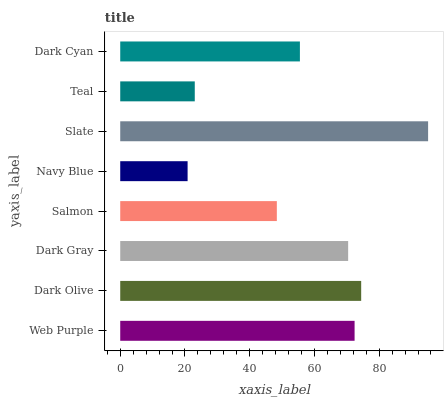Is Navy Blue the minimum?
Answer yes or no. Yes. Is Slate the maximum?
Answer yes or no. Yes. Is Dark Olive the minimum?
Answer yes or no. No. Is Dark Olive the maximum?
Answer yes or no. No. Is Dark Olive greater than Web Purple?
Answer yes or no. Yes. Is Web Purple less than Dark Olive?
Answer yes or no. Yes. Is Web Purple greater than Dark Olive?
Answer yes or no. No. Is Dark Olive less than Web Purple?
Answer yes or no. No. Is Dark Gray the high median?
Answer yes or no. Yes. Is Dark Cyan the low median?
Answer yes or no. Yes. Is Dark Olive the high median?
Answer yes or no. No. Is Navy Blue the low median?
Answer yes or no. No. 